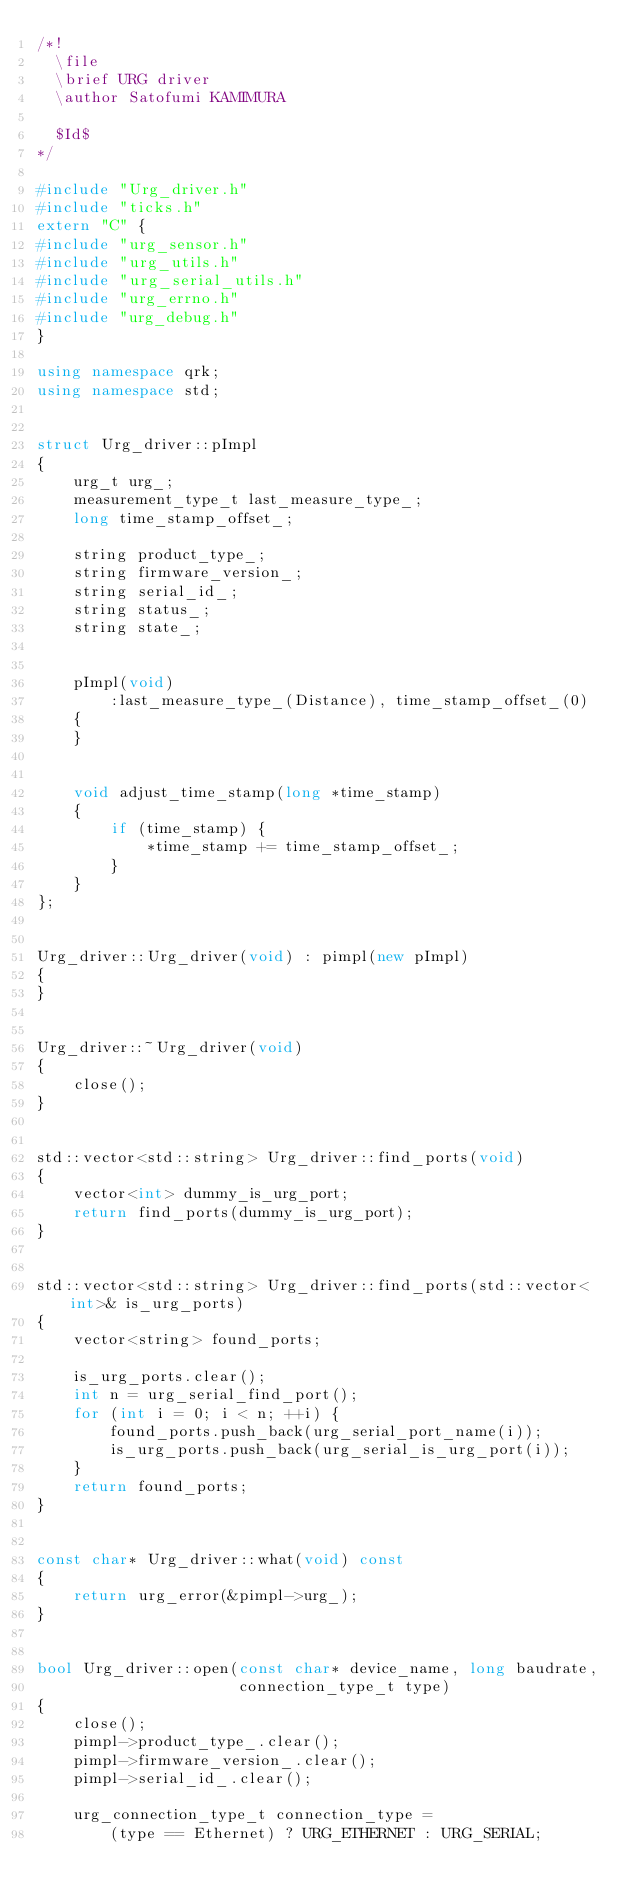<code> <loc_0><loc_0><loc_500><loc_500><_C++_>/*!
  \file
  \brief URG driver
  \author Satofumi KAMIMURA

  $Id$
*/

#include "Urg_driver.h"
#include "ticks.h"
extern "C" {
#include "urg_sensor.h"
#include "urg_utils.h"
#include "urg_serial_utils.h"
#include "urg_errno.h"
#include "urg_debug.h"
}

using namespace qrk;
using namespace std;


struct Urg_driver::pImpl
{
    urg_t urg_;
    measurement_type_t last_measure_type_;
    long time_stamp_offset_;

    string product_type_;
    string firmware_version_;
    string serial_id_;
    string status_;
    string state_;


    pImpl(void)
        :last_measure_type_(Distance), time_stamp_offset_(0)
    {
    }


    void adjust_time_stamp(long *time_stamp)
    {
        if (time_stamp) {
            *time_stamp += time_stamp_offset_;
        }
    }
};


Urg_driver::Urg_driver(void) : pimpl(new pImpl)
{
}


Urg_driver::~Urg_driver(void)
{
    close();
}


std::vector<std::string> Urg_driver::find_ports(void)
{
    vector<int> dummy_is_urg_port;
    return find_ports(dummy_is_urg_port);
}


std::vector<std::string> Urg_driver::find_ports(std::vector<int>& is_urg_ports)
{
    vector<string> found_ports;

    is_urg_ports.clear();
    int n = urg_serial_find_port();
    for (int i = 0; i < n; ++i) {
        found_ports.push_back(urg_serial_port_name(i));
        is_urg_ports.push_back(urg_serial_is_urg_port(i));
    }
    return found_ports;
}


const char* Urg_driver::what(void) const
{
    return urg_error(&pimpl->urg_);
}


bool Urg_driver::open(const char* device_name, long baudrate,
                      connection_type_t type)
{
    close();
    pimpl->product_type_.clear();
    pimpl->firmware_version_.clear();
    pimpl->serial_id_.clear();

    urg_connection_type_t connection_type =
        (type == Ethernet) ? URG_ETHERNET : URG_SERIAL;</code> 